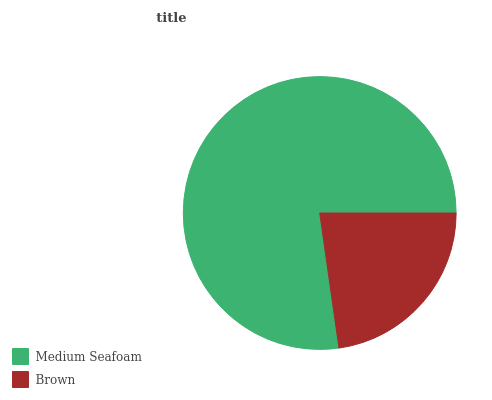Is Brown the minimum?
Answer yes or no. Yes. Is Medium Seafoam the maximum?
Answer yes or no. Yes. Is Brown the maximum?
Answer yes or no. No. Is Medium Seafoam greater than Brown?
Answer yes or no. Yes. Is Brown less than Medium Seafoam?
Answer yes or no. Yes. Is Brown greater than Medium Seafoam?
Answer yes or no. No. Is Medium Seafoam less than Brown?
Answer yes or no. No. Is Medium Seafoam the high median?
Answer yes or no. Yes. Is Brown the low median?
Answer yes or no. Yes. Is Brown the high median?
Answer yes or no. No. Is Medium Seafoam the low median?
Answer yes or no. No. 